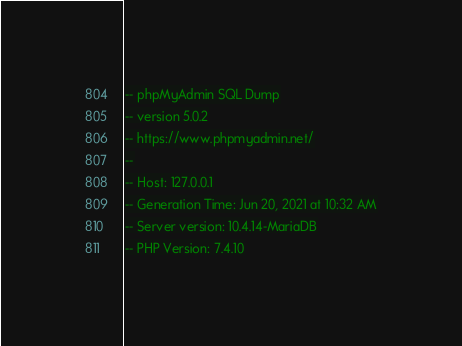<code> <loc_0><loc_0><loc_500><loc_500><_SQL_>-- phpMyAdmin SQL Dump
-- version 5.0.2
-- https://www.phpmyadmin.net/
--
-- Host: 127.0.0.1
-- Generation Time: Jun 20, 2021 at 10:32 AM
-- Server version: 10.4.14-MariaDB
-- PHP Version: 7.4.10
</code> 